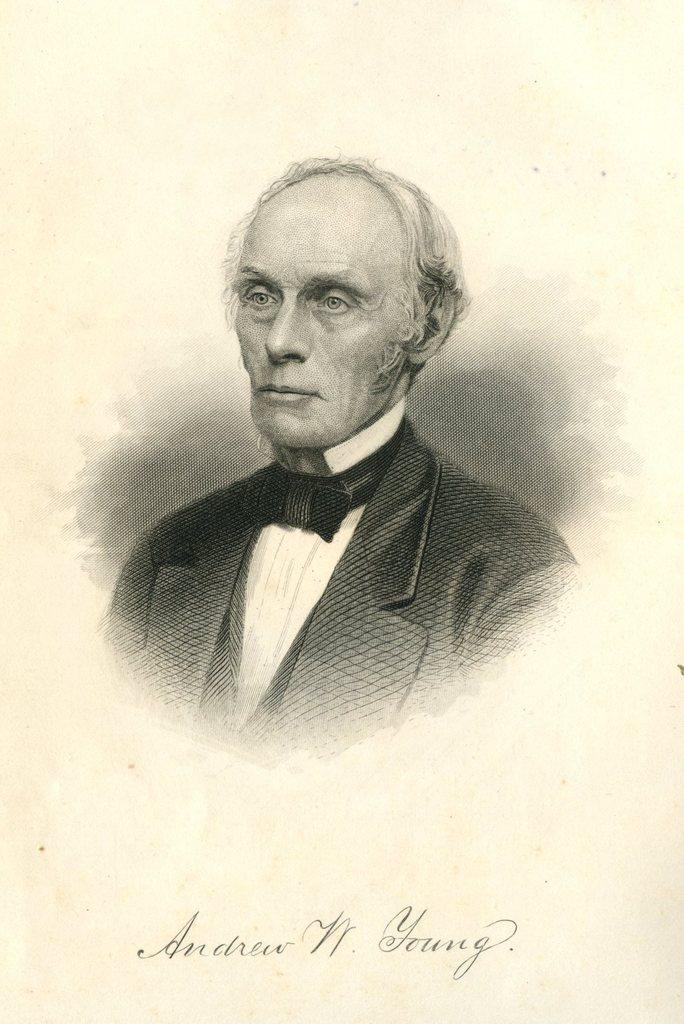What type of artwork is depicted in the image? The image is a painting. Can you describe the main subject of the painting? There is a person wearing a suit in the center of the painting. Is there any text present in the painting? Yes, there is text at the bottom of the painting. How many bears can be seen in the painting? There are no bears present in the painting; it features a person wearing a suit. What type of grape is being sold at the market in the painting? There is no market or grapes depicted in the painting; it only features a person wearing a suit and text at the bottom. 